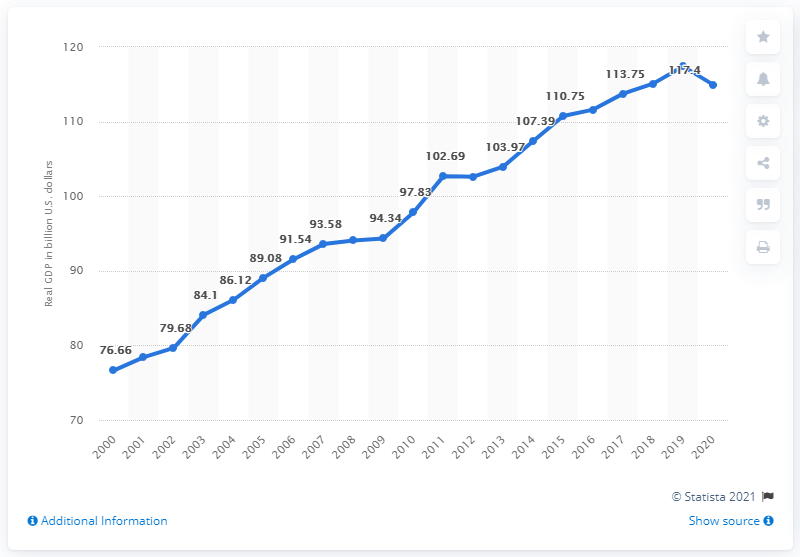Give some essential details in this illustration. In 2020, the Gross Domestic Product (GDP) of Nebraska was 114.96 billion dollars. 